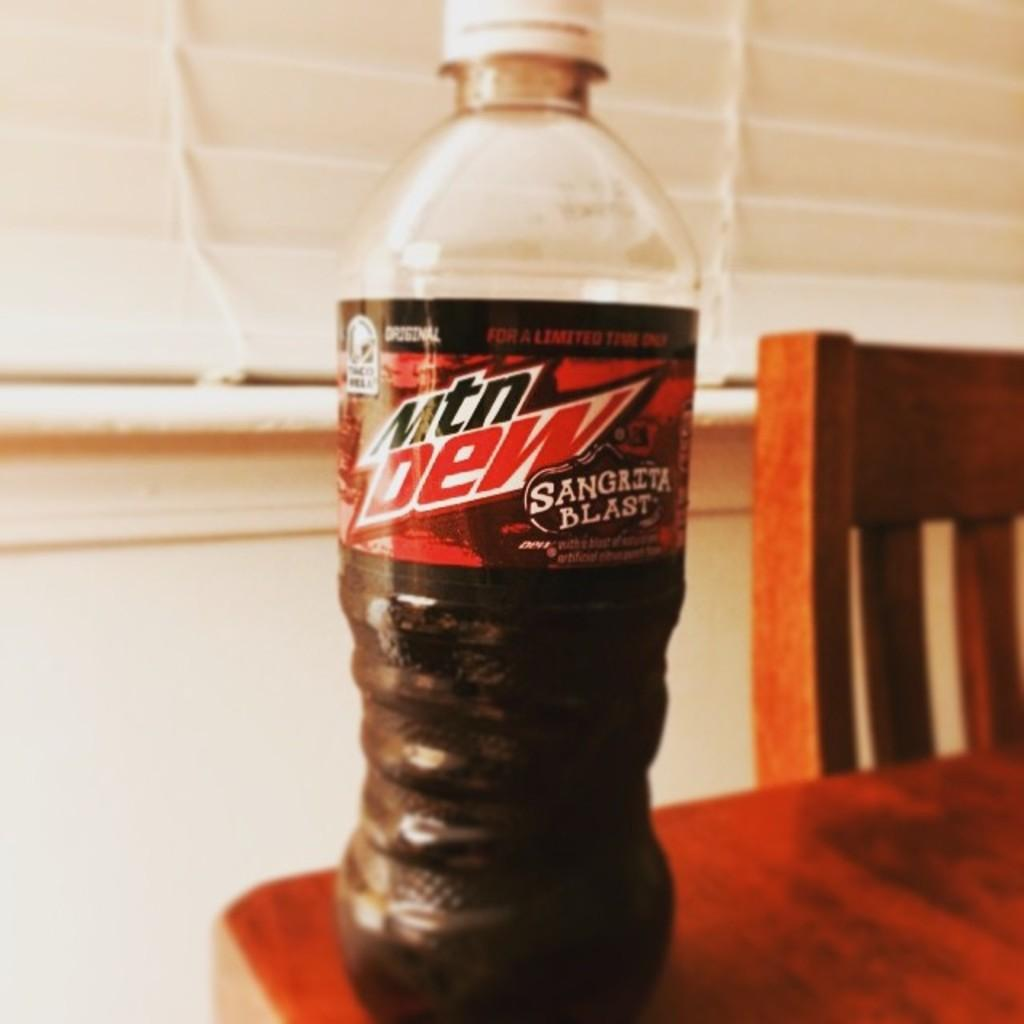What is the main object in the image? There is a juice bottle in the image. Where is the juice bottle located? The juice bottle is placed on a table. How many cows can be seen grazing in the town in the image? There are no cows or towns present in the image; it only features a juice bottle placed on a table. 